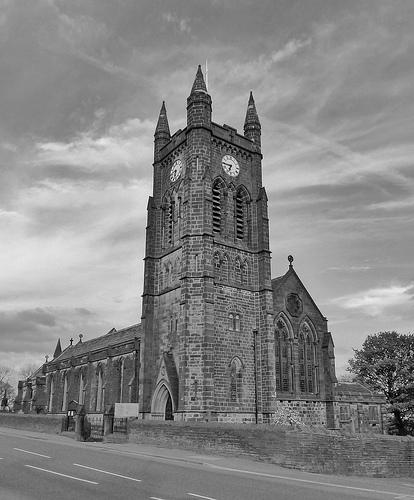Describe the elements present on the road near the church. The road near the church has white traffic lines painted on it, and there is a metal gate and railings in the brick fence. Identify three decorative elements on the church and where they are positioned. There is a rosette-shaped window in the center of one wall, high arched windows with decorative panes, and a decorative octagonal window located near other windows. What type of structure is the building, and what is unique about its walls? The building is a church with old and grey walls, featuring decorative windows and surrounded by a high brick wall. List the different styles of windows in the church and what makes them unique. The church has arched stained glass windows, high arched windows with decorative panes, a rosette-shaped window, a decorative octagonal window, and a long window with slanted panels. These windows are unique due to their shapes, patterns, and decorations. Mention two noteworthy features on the church's tower and explain their appearance. The tower has a pointed roof and two white clock faces displaying Roman numerals and black hands that show the time as 6:45. Identify the primary structure in the image and state its purpose. The primary structure in the image is a church with a large clock tower, serving as a place of worship and showing the time on its clock faces. Identify the objects in the image related to timekeeping and specify their characteristics. There are two white clock faces with black hands and Roman numerals on the church tower, showing the time as 6:45. Describe the position and appearance of the tree within the church property. The tree is on the right side of the church property, leaning to the left and having bushy branches. Describe the surroundings of the church and the condition of the sky. The church is surrounded by a high brick wall, a tall metal gate with stone pillars, and a tree on its property. The sky appears dark. Explain the appearance and location of the main entrance of the building. The main entrance of the building is a thick arched doorway at the tower's base, with a symbol above it and a closed door. Is there a clear and bright road without any markings in front of the church? The image mentions traffic lines and white strips painted on the road, so this instruction contradicts the markings' presence. The church has an open door, inviting people inside. The image says that the door is closed, so this instruction provides incorrect information about the door's state. Notice the wooden fence surrounding the church. The image describes a metal gate and railings in a brick fence but doesn't mention any wooden fence.  Is there a church with bright red walls in the image? The image mentions that the church walls are grey, so this instruction is providing wrong information about the color of the walls. Look for a tree with lots of flowers growing on the left side of the church. The image mentions a "bushy tree leaning left" and "tree growing on the property of the church" on the right side, but there is no mention of a flower tree on the left side. Can you see circular windows on the building? The image mentions various windows, including arched, octagonal, and rosette-shaped, but it doesn't mention any circular windows. There's a blue sky shining above the church. No, it's not mentioned in the image. There's a large pond on the church property. The image mentions several details about the property, such as walls, trees, and gates, but it doesn't mention any pond. Find a large digital clock on the building's tower. The image describes two clock faces with roman numerals but does not mention any digital clock. Identify a tall glass skyscraper near the church. The image does not mention any skyscraper, so this instruction is introducing a nonexistent object. 